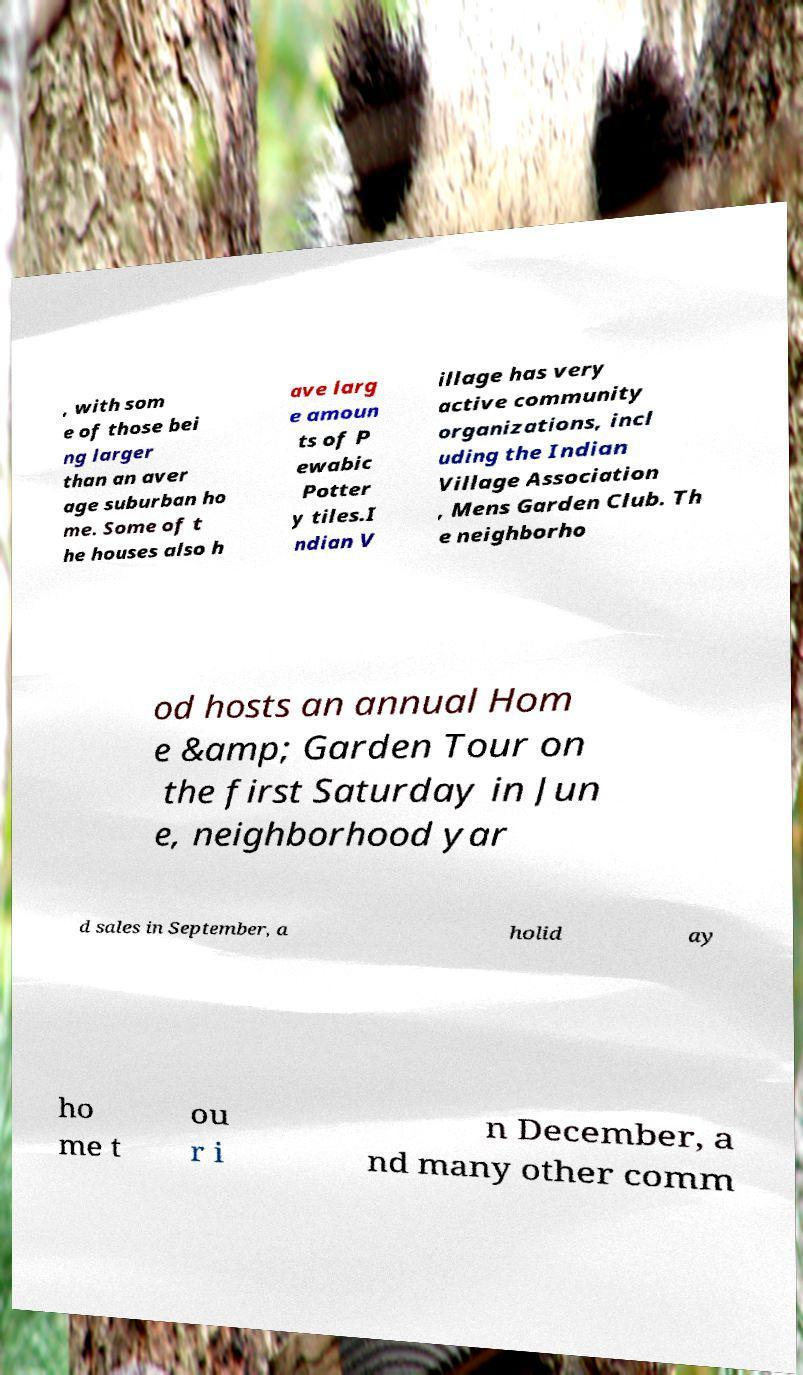Can you read and provide the text displayed in the image?This photo seems to have some interesting text. Can you extract and type it out for me? , with som e of those bei ng larger than an aver age suburban ho me. Some of t he houses also h ave larg e amoun ts of P ewabic Potter y tiles.I ndian V illage has very active community organizations, incl uding the Indian Village Association , Mens Garden Club. Th e neighborho od hosts an annual Hom e &amp; Garden Tour on the first Saturday in Jun e, neighborhood yar d sales in September, a holid ay ho me t ou r i n December, a nd many other comm 